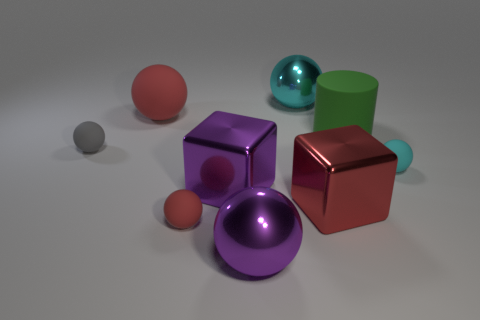Do the red rubber object behind the large green cylinder and the tiny gray matte object have the same shape?
Ensure brevity in your answer.  Yes. What number of other objects are there of the same shape as the green matte object?
Offer a terse response. 0. The big rubber thing that is on the left side of the large green matte cylinder has what shape?
Your answer should be very brief. Sphere. Are there any gray spheres made of the same material as the cylinder?
Offer a terse response. Yes. There is a small ball that is behind the small cyan rubber thing; is it the same color as the rubber cylinder?
Keep it short and to the point. No. What size is the green thing?
Give a very brief answer. Large. There is a ball that is on the right side of the large cyan object on the left side of the big red cube; is there a big purple thing behind it?
Make the answer very short. No. How many large cyan balls are behind the gray thing?
Give a very brief answer. 1. What number of big cubes are the same color as the matte cylinder?
Give a very brief answer. 0. What number of things are red rubber spheres that are behind the green rubber cylinder or metallic spheres that are behind the tiny gray object?
Give a very brief answer. 2. 